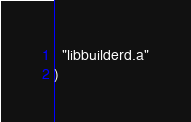Convert code to text. <code><loc_0><loc_0><loc_500><loc_500><_CMake_>  "libbuilderd.a"
)
</code> 